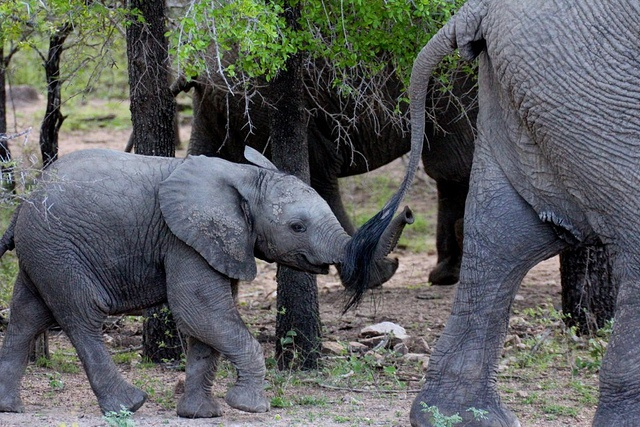Describe the objects in this image and their specific colors. I can see elephant in gray, darkgray, and black tones, elephant in gray, black, and darkgray tones, and elephant in gray, black, darkgreen, and olive tones in this image. 